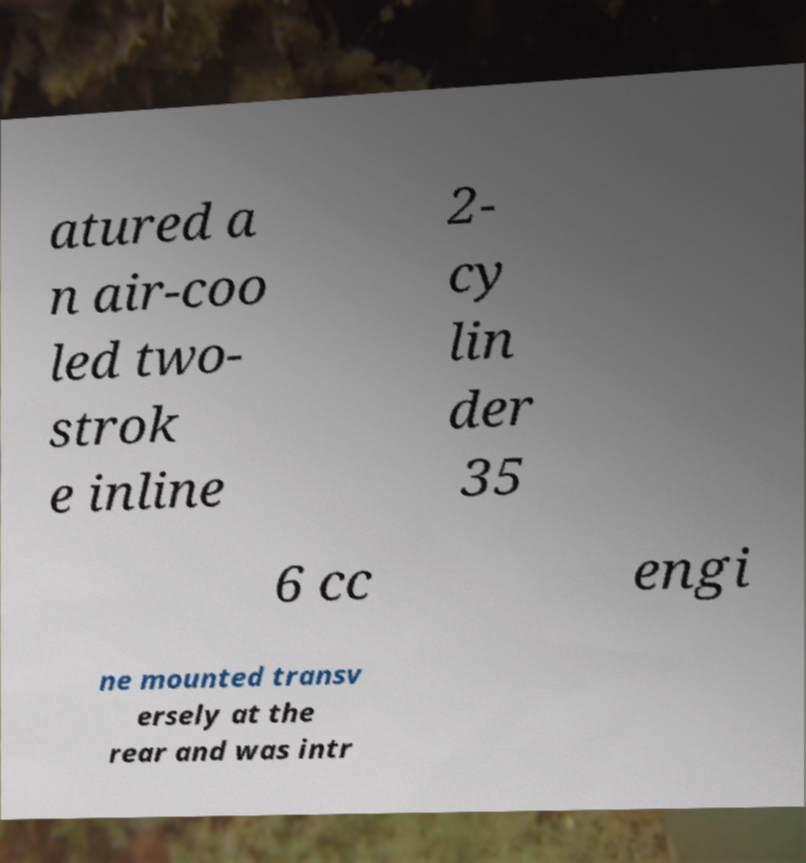I need the written content from this picture converted into text. Can you do that? atured a n air-coo led two- strok e inline 2- cy lin der 35 6 cc engi ne mounted transv ersely at the rear and was intr 